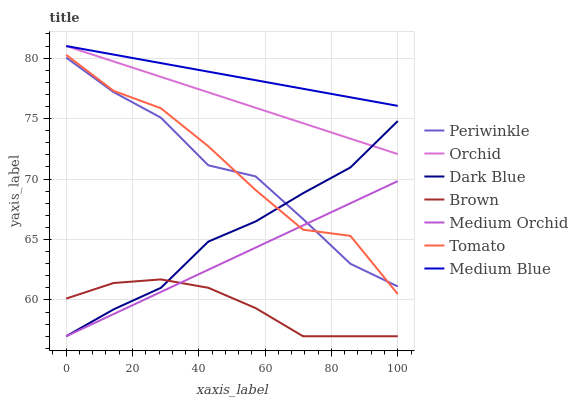Does Brown have the minimum area under the curve?
Answer yes or no. Yes. Does Medium Blue have the maximum area under the curve?
Answer yes or no. Yes. Does Medium Orchid have the minimum area under the curve?
Answer yes or no. No. Does Medium Orchid have the maximum area under the curve?
Answer yes or no. No. Is Medium Blue the smoothest?
Answer yes or no. Yes. Is Tomato the roughest?
Answer yes or no. Yes. Is Brown the smoothest?
Answer yes or no. No. Is Brown the roughest?
Answer yes or no. No. Does Brown have the lowest value?
Answer yes or no. Yes. Does Medium Blue have the lowest value?
Answer yes or no. No. Does Orchid have the highest value?
Answer yes or no. Yes. Does Medium Orchid have the highest value?
Answer yes or no. No. Is Dark Blue less than Medium Blue?
Answer yes or no. Yes. Is Orchid greater than Tomato?
Answer yes or no. Yes. Does Periwinkle intersect Tomato?
Answer yes or no. Yes. Is Periwinkle less than Tomato?
Answer yes or no. No. Is Periwinkle greater than Tomato?
Answer yes or no. No. Does Dark Blue intersect Medium Blue?
Answer yes or no. No. 